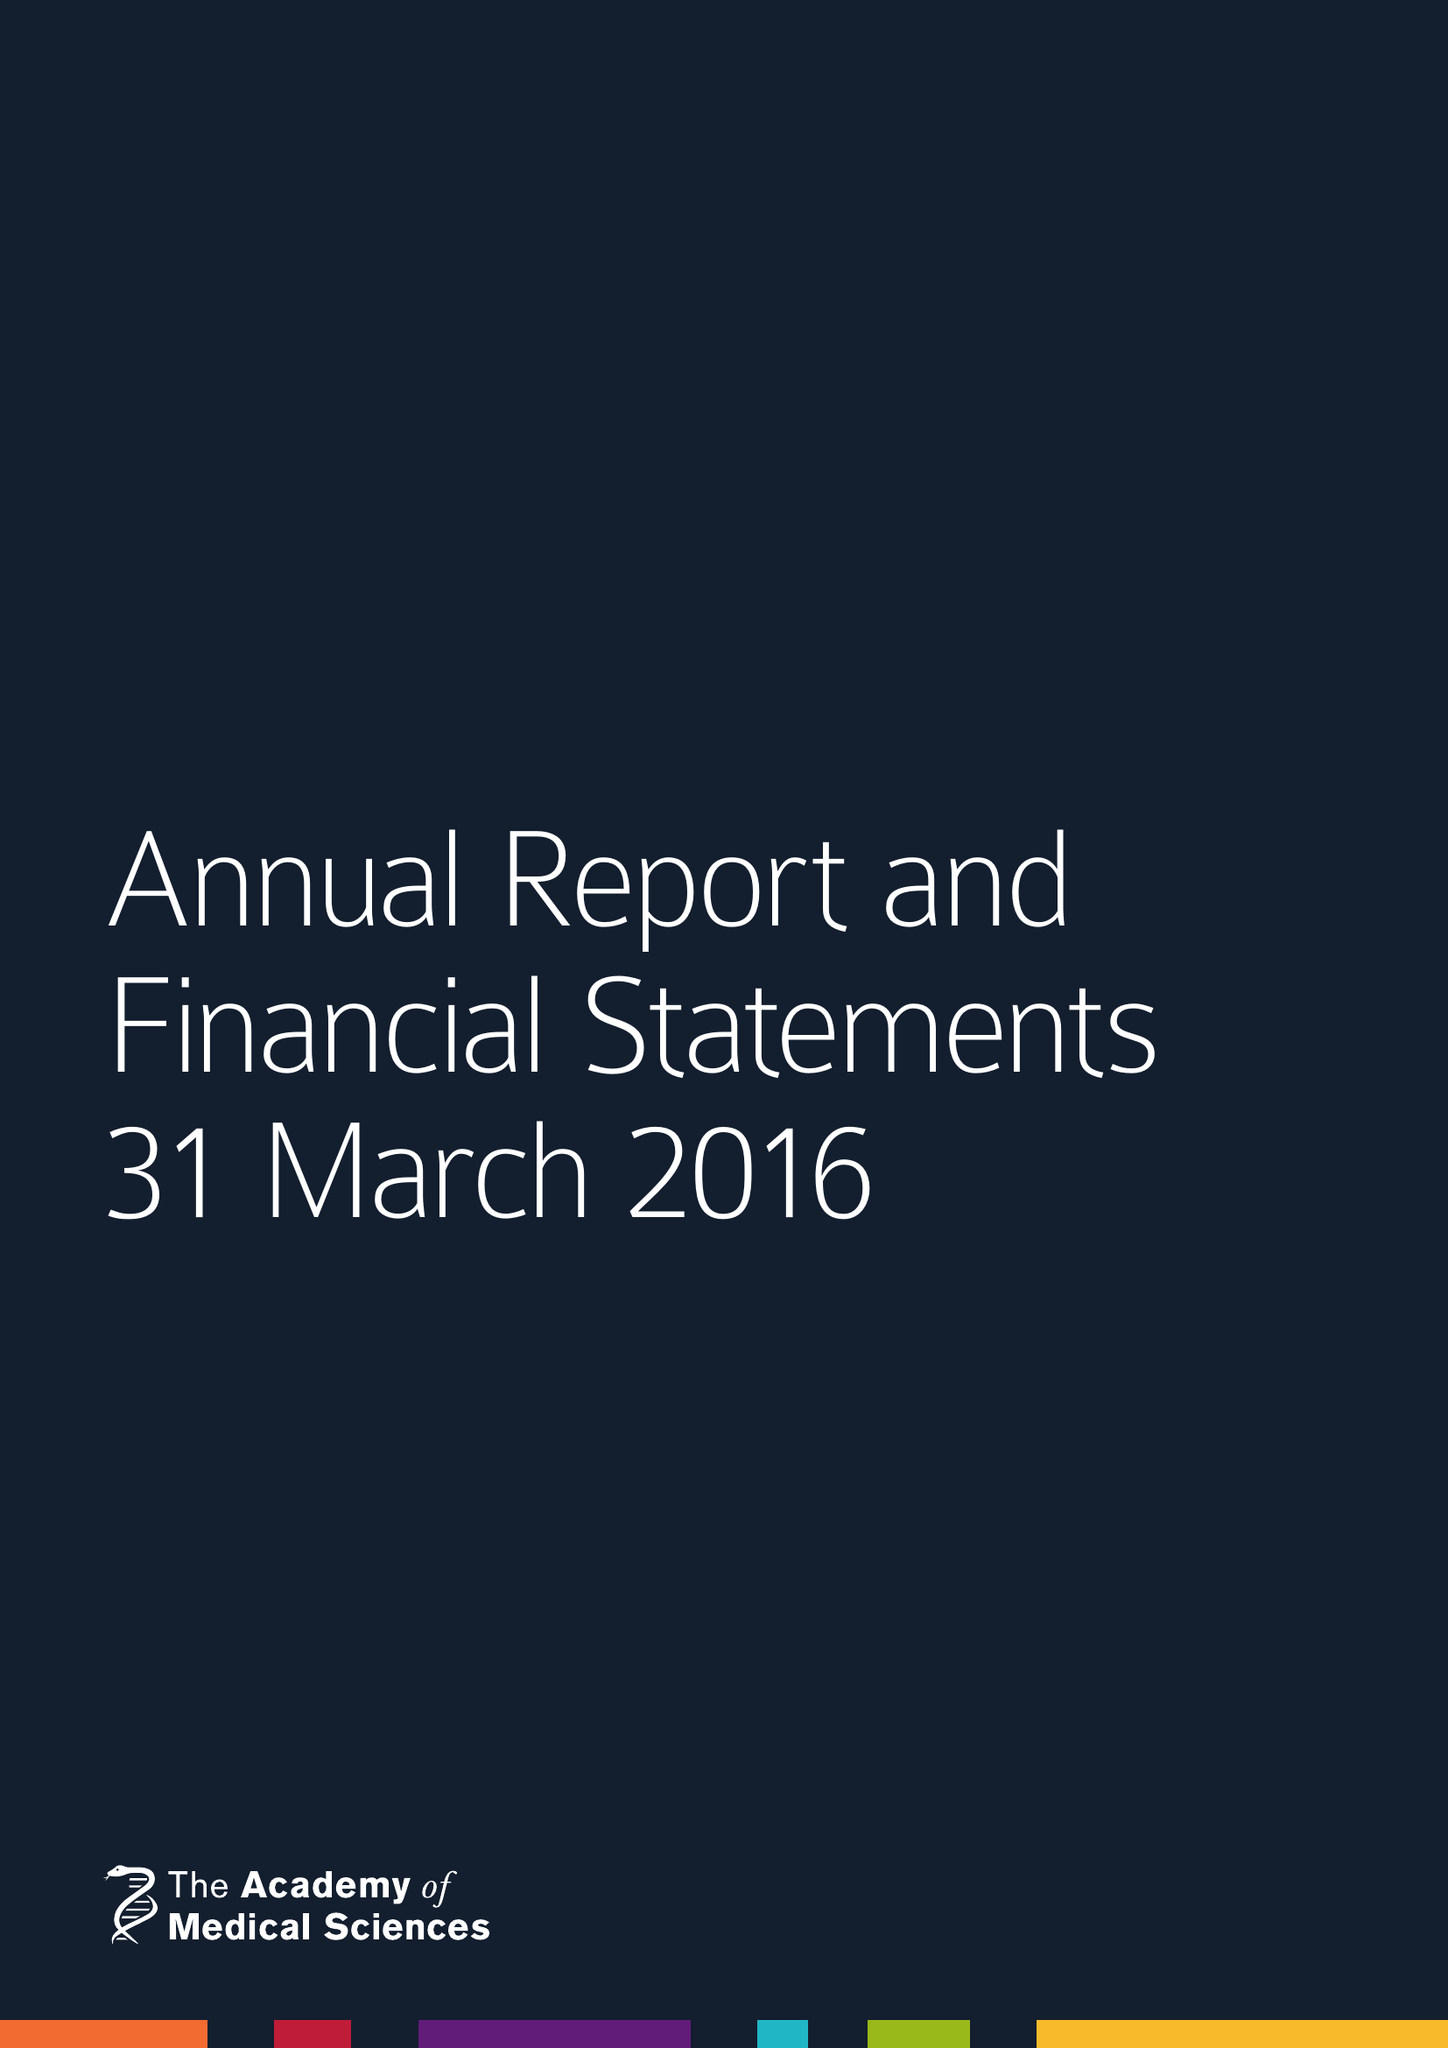What is the value for the address__post_town?
Answer the question using a single word or phrase. LONDON 